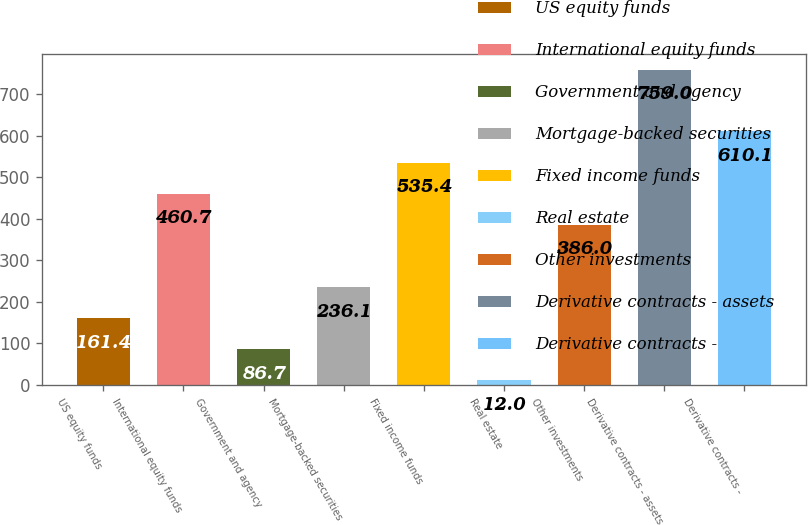<chart> <loc_0><loc_0><loc_500><loc_500><bar_chart><fcel>US equity funds<fcel>International equity funds<fcel>Government and agency<fcel>Mortgage-backed securities<fcel>Fixed income funds<fcel>Real estate<fcel>Other investments<fcel>Derivative contracts - assets<fcel>Derivative contracts -<nl><fcel>161.4<fcel>460.7<fcel>86.7<fcel>236.1<fcel>535.4<fcel>12<fcel>386<fcel>759<fcel>610.1<nl></chart> 